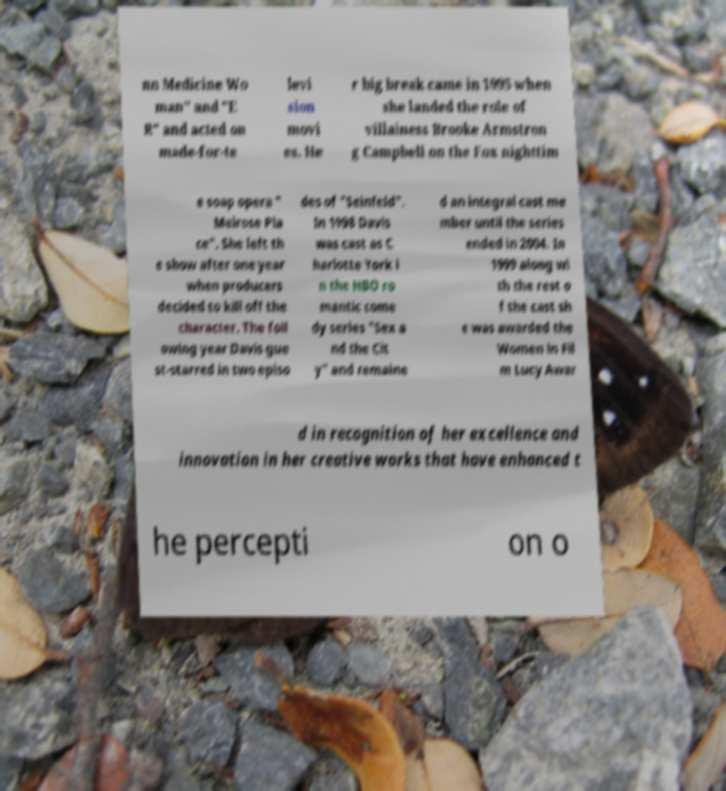Could you extract and type out the text from this image? nn Medicine Wo man" and "E R" and acted on made-for-te levi sion movi es. He r big break came in 1995 when she landed the role of villainess Brooke Armstron g Campbell on the Fox nighttim e soap opera " Melrose Pla ce". She left th e show after one year when producers decided to kill off the character. The foll owing year Davis gue st-starred in two episo des of "Seinfeld". In 1998 Davis was cast as C harlotte York i n the HBO ro mantic come dy series "Sex a nd the Cit y" and remaine d an integral cast me mber until the series ended in 2004. In 1999 along wi th the rest o f the cast sh e was awarded the Women in Fil m Lucy Awar d in recognition of her excellence and innovation in her creative works that have enhanced t he percepti on o 